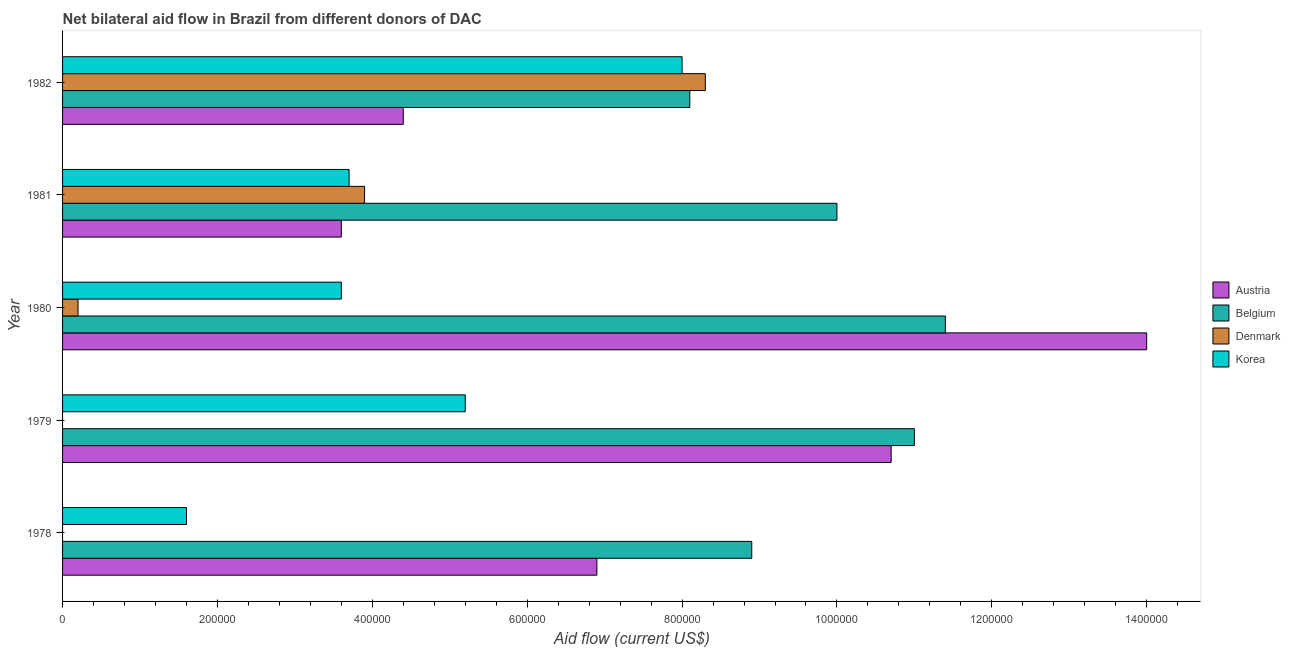Are the number of bars per tick equal to the number of legend labels?
Your answer should be compact. No. Are the number of bars on each tick of the Y-axis equal?
Your answer should be compact. No. How many bars are there on the 1st tick from the bottom?
Give a very brief answer. 3. What is the label of the 3rd group of bars from the top?
Give a very brief answer. 1980. In how many cases, is the number of bars for a given year not equal to the number of legend labels?
Offer a very short reply. 2. What is the amount of aid given by korea in 1979?
Make the answer very short. 5.20e+05. Across all years, what is the maximum amount of aid given by belgium?
Your answer should be compact. 1.14e+06. Across all years, what is the minimum amount of aid given by belgium?
Offer a terse response. 8.10e+05. What is the total amount of aid given by korea in the graph?
Give a very brief answer. 2.21e+06. What is the difference between the amount of aid given by austria in 1980 and that in 1982?
Keep it short and to the point. 9.60e+05. What is the difference between the amount of aid given by korea in 1981 and the amount of aid given by austria in 1979?
Your answer should be very brief. -7.00e+05. What is the average amount of aid given by austria per year?
Offer a terse response. 7.92e+05. In the year 1979, what is the difference between the amount of aid given by belgium and amount of aid given by korea?
Your answer should be very brief. 5.80e+05. In how many years, is the amount of aid given by austria greater than 560000 US$?
Provide a short and direct response. 3. What is the ratio of the amount of aid given by belgium in 1979 to that in 1982?
Provide a short and direct response. 1.36. Is the difference between the amount of aid given by denmark in 1980 and 1981 greater than the difference between the amount of aid given by austria in 1980 and 1981?
Offer a terse response. No. What is the difference between the highest and the second highest amount of aid given by denmark?
Ensure brevity in your answer.  4.40e+05. What is the difference between the highest and the lowest amount of aid given by austria?
Offer a very short reply. 1.04e+06. Is the sum of the amount of aid given by belgium in 1979 and 1982 greater than the maximum amount of aid given by korea across all years?
Offer a very short reply. Yes. Are all the bars in the graph horizontal?
Offer a very short reply. Yes. What is the difference between two consecutive major ticks on the X-axis?
Ensure brevity in your answer.  2.00e+05. Does the graph contain any zero values?
Provide a succinct answer. Yes. Where does the legend appear in the graph?
Your answer should be compact. Center right. How many legend labels are there?
Your response must be concise. 4. What is the title of the graph?
Provide a short and direct response. Net bilateral aid flow in Brazil from different donors of DAC. What is the Aid flow (current US$) of Austria in 1978?
Ensure brevity in your answer.  6.90e+05. What is the Aid flow (current US$) of Belgium in 1978?
Provide a short and direct response. 8.90e+05. What is the Aid flow (current US$) in Korea in 1978?
Offer a very short reply. 1.60e+05. What is the Aid flow (current US$) in Austria in 1979?
Give a very brief answer. 1.07e+06. What is the Aid flow (current US$) in Belgium in 1979?
Give a very brief answer. 1.10e+06. What is the Aid flow (current US$) in Korea in 1979?
Your answer should be compact. 5.20e+05. What is the Aid flow (current US$) of Austria in 1980?
Offer a terse response. 1.40e+06. What is the Aid flow (current US$) in Belgium in 1980?
Make the answer very short. 1.14e+06. What is the Aid flow (current US$) in Denmark in 1980?
Keep it short and to the point. 2.00e+04. What is the Aid flow (current US$) in Korea in 1980?
Provide a short and direct response. 3.60e+05. What is the Aid flow (current US$) of Austria in 1981?
Your answer should be very brief. 3.60e+05. What is the Aid flow (current US$) in Denmark in 1981?
Your answer should be compact. 3.90e+05. What is the Aid flow (current US$) of Austria in 1982?
Keep it short and to the point. 4.40e+05. What is the Aid flow (current US$) in Belgium in 1982?
Give a very brief answer. 8.10e+05. What is the Aid flow (current US$) of Denmark in 1982?
Your response must be concise. 8.30e+05. Across all years, what is the maximum Aid flow (current US$) of Austria?
Your answer should be compact. 1.40e+06. Across all years, what is the maximum Aid flow (current US$) of Belgium?
Offer a very short reply. 1.14e+06. Across all years, what is the maximum Aid flow (current US$) in Denmark?
Your answer should be very brief. 8.30e+05. Across all years, what is the maximum Aid flow (current US$) in Korea?
Offer a terse response. 8.00e+05. Across all years, what is the minimum Aid flow (current US$) of Austria?
Ensure brevity in your answer.  3.60e+05. Across all years, what is the minimum Aid flow (current US$) of Belgium?
Give a very brief answer. 8.10e+05. What is the total Aid flow (current US$) of Austria in the graph?
Your response must be concise. 3.96e+06. What is the total Aid flow (current US$) in Belgium in the graph?
Ensure brevity in your answer.  4.94e+06. What is the total Aid flow (current US$) in Denmark in the graph?
Offer a terse response. 1.24e+06. What is the total Aid flow (current US$) in Korea in the graph?
Provide a short and direct response. 2.21e+06. What is the difference between the Aid flow (current US$) of Austria in 1978 and that in 1979?
Provide a short and direct response. -3.80e+05. What is the difference between the Aid flow (current US$) in Belgium in 1978 and that in 1979?
Your answer should be very brief. -2.10e+05. What is the difference between the Aid flow (current US$) of Korea in 1978 and that in 1979?
Give a very brief answer. -3.60e+05. What is the difference between the Aid flow (current US$) in Austria in 1978 and that in 1980?
Your answer should be compact. -7.10e+05. What is the difference between the Aid flow (current US$) of Belgium in 1978 and that in 1980?
Your answer should be compact. -2.50e+05. What is the difference between the Aid flow (current US$) of Austria in 1978 and that in 1981?
Provide a short and direct response. 3.30e+05. What is the difference between the Aid flow (current US$) in Belgium in 1978 and that in 1981?
Make the answer very short. -1.10e+05. What is the difference between the Aid flow (current US$) in Austria in 1978 and that in 1982?
Ensure brevity in your answer.  2.50e+05. What is the difference between the Aid flow (current US$) in Belgium in 1978 and that in 1982?
Your response must be concise. 8.00e+04. What is the difference between the Aid flow (current US$) in Korea in 1978 and that in 1982?
Your response must be concise. -6.40e+05. What is the difference between the Aid flow (current US$) of Austria in 1979 and that in 1980?
Give a very brief answer. -3.30e+05. What is the difference between the Aid flow (current US$) of Austria in 1979 and that in 1981?
Make the answer very short. 7.10e+05. What is the difference between the Aid flow (current US$) in Korea in 1979 and that in 1981?
Your response must be concise. 1.50e+05. What is the difference between the Aid flow (current US$) of Austria in 1979 and that in 1982?
Your answer should be very brief. 6.30e+05. What is the difference between the Aid flow (current US$) of Korea in 1979 and that in 1982?
Make the answer very short. -2.80e+05. What is the difference between the Aid flow (current US$) of Austria in 1980 and that in 1981?
Your response must be concise. 1.04e+06. What is the difference between the Aid flow (current US$) of Denmark in 1980 and that in 1981?
Ensure brevity in your answer.  -3.70e+05. What is the difference between the Aid flow (current US$) in Korea in 1980 and that in 1981?
Provide a succinct answer. -10000. What is the difference between the Aid flow (current US$) of Austria in 1980 and that in 1982?
Give a very brief answer. 9.60e+05. What is the difference between the Aid flow (current US$) of Belgium in 1980 and that in 1982?
Keep it short and to the point. 3.30e+05. What is the difference between the Aid flow (current US$) in Denmark in 1980 and that in 1982?
Offer a terse response. -8.10e+05. What is the difference between the Aid flow (current US$) in Korea in 1980 and that in 1982?
Keep it short and to the point. -4.40e+05. What is the difference between the Aid flow (current US$) of Austria in 1981 and that in 1982?
Your answer should be very brief. -8.00e+04. What is the difference between the Aid flow (current US$) in Denmark in 1981 and that in 1982?
Give a very brief answer. -4.40e+05. What is the difference between the Aid flow (current US$) in Korea in 1981 and that in 1982?
Your answer should be very brief. -4.30e+05. What is the difference between the Aid flow (current US$) in Austria in 1978 and the Aid flow (current US$) in Belgium in 1979?
Offer a very short reply. -4.10e+05. What is the difference between the Aid flow (current US$) in Austria in 1978 and the Aid flow (current US$) in Korea in 1979?
Provide a succinct answer. 1.70e+05. What is the difference between the Aid flow (current US$) in Austria in 1978 and the Aid flow (current US$) in Belgium in 1980?
Give a very brief answer. -4.50e+05. What is the difference between the Aid flow (current US$) in Austria in 1978 and the Aid flow (current US$) in Denmark in 1980?
Ensure brevity in your answer.  6.70e+05. What is the difference between the Aid flow (current US$) in Belgium in 1978 and the Aid flow (current US$) in Denmark in 1980?
Your response must be concise. 8.70e+05. What is the difference between the Aid flow (current US$) in Belgium in 1978 and the Aid flow (current US$) in Korea in 1980?
Provide a short and direct response. 5.30e+05. What is the difference between the Aid flow (current US$) of Austria in 1978 and the Aid flow (current US$) of Belgium in 1981?
Offer a terse response. -3.10e+05. What is the difference between the Aid flow (current US$) in Belgium in 1978 and the Aid flow (current US$) in Korea in 1981?
Make the answer very short. 5.20e+05. What is the difference between the Aid flow (current US$) of Austria in 1978 and the Aid flow (current US$) of Korea in 1982?
Make the answer very short. -1.10e+05. What is the difference between the Aid flow (current US$) in Belgium in 1978 and the Aid flow (current US$) in Denmark in 1982?
Give a very brief answer. 6.00e+04. What is the difference between the Aid flow (current US$) in Belgium in 1978 and the Aid flow (current US$) in Korea in 1982?
Offer a terse response. 9.00e+04. What is the difference between the Aid flow (current US$) of Austria in 1979 and the Aid flow (current US$) of Belgium in 1980?
Make the answer very short. -7.00e+04. What is the difference between the Aid flow (current US$) of Austria in 1979 and the Aid flow (current US$) of Denmark in 1980?
Provide a short and direct response. 1.05e+06. What is the difference between the Aid flow (current US$) of Austria in 1979 and the Aid flow (current US$) of Korea in 1980?
Provide a short and direct response. 7.10e+05. What is the difference between the Aid flow (current US$) in Belgium in 1979 and the Aid flow (current US$) in Denmark in 1980?
Your response must be concise. 1.08e+06. What is the difference between the Aid flow (current US$) of Belgium in 1979 and the Aid flow (current US$) of Korea in 1980?
Provide a succinct answer. 7.40e+05. What is the difference between the Aid flow (current US$) of Austria in 1979 and the Aid flow (current US$) of Belgium in 1981?
Offer a very short reply. 7.00e+04. What is the difference between the Aid flow (current US$) of Austria in 1979 and the Aid flow (current US$) of Denmark in 1981?
Your answer should be very brief. 6.80e+05. What is the difference between the Aid flow (current US$) in Austria in 1979 and the Aid flow (current US$) in Korea in 1981?
Offer a terse response. 7.00e+05. What is the difference between the Aid flow (current US$) of Belgium in 1979 and the Aid flow (current US$) of Denmark in 1981?
Make the answer very short. 7.10e+05. What is the difference between the Aid flow (current US$) in Belgium in 1979 and the Aid flow (current US$) in Korea in 1981?
Keep it short and to the point. 7.30e+05. What is the difference between the Aid flow (current US$) of Austria in 1979 and the Aid flow (current US$) of Belgium in 1982?
Offer a very short reply. 2.60e+05. What is the difference between the Aid flow (current US$) of Austria in 1979 and the Aid flow (current US$) of Denmark in 1982?
Offer a terse response. 2.40e+05. What is the difference between the Aid flow (current US$) of Austria in 1979 and the Aid flow (current US$) of Korea in 1982?
Keep it short and to the point. 2.70e+05. What is the difference between the Aid flow (current US$) in Belgium in 1979 and the Aid flow (current US$) in Denmark in 1982?
Offer a terse response. 2.70e+05. What is the difference between the Aid flow (current US$) of Austria in 1980 and the Aid flow (current US$) of Belgium in 1981?
Give a very brief answer. 4.00e+05. What is the difference between the Aid flow (current US$) in Austria in 1980 and the Aid flow (current US$) in Denmark in 1981?
Offer a terse response. 1.01e+06. What is the difference between the Aid flow (current US$) in Austria in 1980 and the Aid flow (current US$) in Korea in 1981?
Provide a succinct answer. 1.03e+06. What is the difference between the Aid flow (current US$) in Belgium in 1980 and the Aid flow (current US$) in Denmark in 1981?
Provide a short and direct response. 7.50e+05. What is the difference between the Aid flow (current US$) in Belgium in 1980 and the Aid flow (current US$) in Korea in 1981?
Offer a terse response. 7.70e+05. What is the difference between the Aid flow (current US$) in Denmark in 1980 and the Aid flow (current US$) in Korea in 1981?
Keep it short and to the point. -3.50e+05. What is the difference between the Aid flow (current US$) in Austria in 1980 and the Aid flow (current US$) in Belgium in 1982?
Make the answer very short. 5.90e+05. What is the difference between the Aid flow (current US$) in Austria in 1980 and the Aid flow (current US$) in Denmark in 1982?
Your answer should be very brief. 5.70e+05. What is the difference between the Aid flow (current US$) in Austria in 1980 and the Aid flow (current US$) in Korea in 1982?
Ensure brevity in your answer.  6.00e+05. What is the difference between the Aid flow (current US$) in Belgium in 1980 and the Aid flow (current US$) in Denmark in 1982?
Your answer should be very brief. 3.10e+05. What is the difference between the Aid flow (current US$) in Belgium in 1980 and the Aid flow (current US$) in Korea in 1982?
Your response must be concise. 3.40e+05. What is the difference between the Aid flow (current US$) in Denmark in 1980 and the Aid flow (current US$) in Korea in 1982?
Your response must be concise. -7.80e+05. What is the difference between the Aid flow (current US$) in Austria in 1981 and the Aid flow (current US$) in Belgium in 1982?
Keep it short and to the point. -4.50e+05. What is the difference between the Aid flow (current US$) in Austria in 1981 and the Aid flow (current US$) in Denmark in 1982?
Provide a succinct answer. -4.70e+05. What is the difference between the Aid flow (current US$) of Austria in 1981 and the Aid flow (current US$) of Korea in 1982?
Provide a succinct answer. -4.40e+05. What is the difference between the Aid flow (current US$) in Belgium in 1981 and the Aid flow (current US$) in Denmark in 1982?
Your answer should be compact. 1.70e+05. What is the difference between the Aid flow (current US$) in Belgium in 1981 and the Aid flow (current US$) in Korea in 1982?
Ensure brevity in your answer.  2.00e+05. What is the difference between the Aid flow (current US$) in Denmark in 1981 and the Aid flow (current US$) in Korea in 1982?
Give a very brief answer. -4.10e+05. What is the average Aid flow (current US$) in Austria per year?
Give a very brief answer. 7.92e+05. What is the average Aid flow (current US$) in Belgium per year?
Offer a terse response. 9.88e+05. What is the average Aid flow (current US$) of Denmark per year?
Provide a short and direct response. 2.48e+05. What is the average Aid flow (current US$) in Korea per year?
Make the answer very short. 4.42e+05. In the year 1978, what is the difference between the Aid flow (current US$) in Austria and Aid flow (current US$) in Korea?
Make the answer very short. 5.30e+05. In the year 1978, what is the difference between the Aid flow (current US$) in Belgium and Aid flow (current US$) in Korea?
Provide a succinct answer. 7.30e+05. In the year 1979, what is the difference between the Aid flow (current US$) in Austria and Aid flow (current US$) in Belgium?
Provide a short and direct response. -3.00e+04. In the year 1979, what is the difference between the Aid flow (current US$) of Austria and Aid flow (current US$) of Korea?
Keep it short and to the point. 5.50e+05. In the year 1979, what is the difference between the Aid flow (current US$) of Belgium and Aid flow (current US$) of Korea?
Your response must be concise. 5.80e+05. In the year 1980, what is the difference between the Aid flow (current US$) in Austria and Aid flow (current US$) in Denmark?
Give a very brief answer. 1.38e+06. In the year 1980, what is the difference between the Aid flow (current US$) in Austria and Aid flow (current US$) in Korea?
Your answer should be very brief. 1.04e+06. In the year 1980, what is the difference between the Aid flow (current US$) of Belgium and Aid flow (current US$) of Denmark?
Your response must be concise. 1.12e+06. In the year 1980, what is the difference between the Aid flow (current US$) of Belgium and Aid flow (current US$) of Korea?
Offer a terse response. 7.80e+05. In the year 1981, what is the difference between the Aid flow (current US$) of Austria and Aid flow (current US$) of Belgium?
Your answer should be very brief. -6.40e+05. In the year 1981, what is the difference between the Aid flow (current US$) of Austria and Aid flow (current US$) of Denmark?
Keep it short and to the point. -3.00e+04. In the year 1981, what is the difference between the Aid flow (current US$) of Austria and Aid flow (current US$) of Korea?
Your response must be concise. -10000. In the year 1981, what is the difference between the Aid flow (current US$) of Belgium and Aid flow (current US$) of Korea?
Your answer should be very brief. 6.30e+05. In the year 1981, what is the difference between the Aid flow (current US$) of Denmark and Aid flow (current US$) of Korea?
Keep it short and to the point. 2.00e+04. In the year 1982, what is the difference between the Aid flow (current US$) of Austria and Aid flow (current US$) of Belgium?
Give a very brief answer. -3.70e+05. In the year 1982, what is the difference between the Aid flow (current US$) of Austria and Aid flow (current US$) of Denmark?
Provide a short and direct response. -3.90e+05. In the year 1982, what is the difference between the Aid flow (current US$) of Austria and Aid flow (current US$) of Korea?
Provide a succinct answer. -3.60e+05. In the year 1982, what is the difference between the Aid flow (current US$) of Belgium and Aid flow (current US$) of Korea?
Give a very brief answer. 10000. What is the ratio of the Aid flow (current US$) in Austria in 1978 to that in 1979?
Your answer should be very brief. 0.64. What is the ratio of the Aid flow (current US$) of Belgium in 1978 to that in 1979?
Offer a very short reply. 0.81. What is the ratio of the Aid flow (current US$) in Korea in 1978 to that in 1979?
Keep it short and to the point. 0.31. What is the ratio of the Aid flow (current US$) of Austria in 1978 to that in 1980?
Keep it short and to the point. 0.49. What is the ratio of the Aid flow (current US$) of Belgium in 1978 to that in 1980?
Give a very brief answer. 0.78. What is the ratio of the Aid flow (current US$) of Korea in 1978 to that in 1980?
Your answer should be very brief. 0.44. What is the ratio of the Aid flow (current US$) in Austria in 1978 to that in 1981?
Provide a succinct answer. 1.92. What is the ratio of the Aid flow (current US$) of Belgium in 1978 to that in 1981?
Give a very brief answer. 0.89. What is the ratio of the Aid flow (current US$) of Korea in 1978 to that in 1981?
Offer a very short reply. 0.43. What is the ratio of the Aid flow (current US$) of Austria in 1978 to that in 1982?
Your answer should be very brief. 1.57. What is the ratio of the Aid flow (current US$) of Belgium in 1978 to that in 1982?
Your answer should be very brief. 1.1. What is the ratio of the Aid flow (current US$) of Korea in 1978 to that in 1982?
Your answer should be compact. 0.2. What is the ratio of the Aid flow (current US$) of Austria in 1979 to that in 1980?
Your answer should be compact. 0.76. What is the ratio of the Aid flow (current US$) in Belgium in 1979 to that in 1980?
Your answer should be very brief. 0.96. What is the ratio of the Aid flow (current US$) of Korea in 1979 to that in 1980?
Provide a succinct answer. 1.44. What is the ratio of the Aid flow (current US$) of Austria in 1979 to that in 1981?
Provide a succinct answer. 2.97. What is the ratio of the Aid flow (current US$) of Korea in 1979 to that in 1981?
Give a very brief answer. 1.41. What is the ratio of the Aid flow (current US$) of Austria in 1979 to that in 1982?
Your response must be concise. 2.43. What is the ratio of the Aid flow (current US$) in Belgium in 1979 to that in 1982?
Your answer should be very brief. 1.36. What is the ratio of the Aid flow (current US$) of Korea in 1979 to that in 1982?
Offer a very short reply. 0.65. What is the ratio of the Aid flow (current US$) of Austria in 1980 to that in 1981?
Give a very brief answer. 3.89. What is the ratio of the Aid flow (current US$) of Belgium in 1980 to that in 1981?
Offer a terse response. 1.14. What is the ratio of the Aid flow (current US$) of Denmark in 1980 to that in 1981?
Offer a very short reply. 0.05. What is the ratio of the Aid flow (current US$) of Austria in 1980 to that in 1982?
Your response must be concise. 3.18. What is the ratio of the Aid flow (current US$) of Belgium in 1980 to that in 1982?
Keep it short and to the point. 1.41. What is the ratio of the Aid flow (current US$) in Denmark in 1980 to that in 1982?
Give a very brief answer. 0.02. What is the ratio of the Aid flow (current US$) in Korea in 1980 to that in 1982?
Keep it short and to the point. 0.45. What is the ratio of the Aid flow (current US$) in Austria in 1981 to that in 1982?
Make the answer very short. 0.82. What is the ratio of the Aid flow (current US$) in Belgium in 1981 to that in 1982?
Give a very brief answer. 1.23. What is the ratio of the Aid flow (current US$) in Denmark in 1981 to that in 1982?
Your response must be concise. 0.47. What is the ratio of the Aid flow (current US$) in Korea in 1981 to that in 1982?
Offer a terse response. 0.46. What is the difference between the highest and the second highest Aid flow (current US$) in Korea?
Offer a terse response. 2.80e+05. What is the difference between the highest and the lowest Aid flow (current US$) of Austria?
Make the answer very short. 1.04e+06. What is the difference between the highest and the lowest Aid flow (current US$) in Denmark?
Ensure brevity in your answer.  8.30e+05. What is the difference between the highest and the lowest Aid flow (current US$) of Korea?
Make the answer very short. 6.40e+05. 